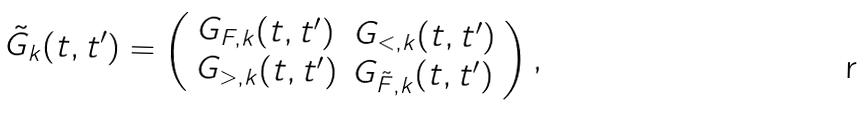Convert formula to latex. <formula><loc_0><loc_0><loc_500><loc_500>\tilde { G } _ { k } ( t , t ^ { \prime } ) = \left ( \begin{array} { l l } G _ { F , k } ( t , t ^ { \prime } ) & G _ { < , k } ( t , t ^ { \prime } ) \\ G _ { > , k } ( t , t ^ { \prime } ) & G _ { \tilde { F } , k } ( t , t ^ { \prime } ) \end{array} \right ) ,</formula> 